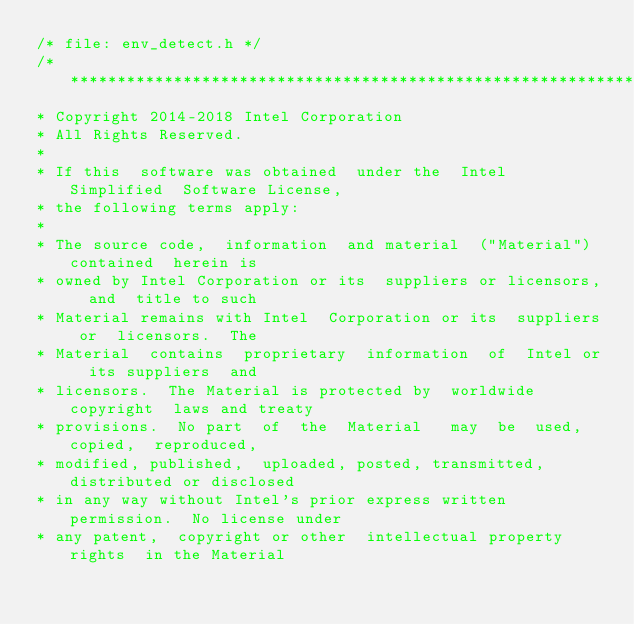<code> <loc_0><loc_0><loc_500><loc_500><_C_>/* file: env_detect.h */
/*******************************************************************************
* Copyright 2014-2018 Intel Corporation
* All Rights Reserved.
*
* If this  software was obtained  under the  Intel Simplified  Software License,
* the following terms apply:
*
* The source code,  information  and material  ("Material") contained  herein is
* owned by Intel Corporation or its  suppliers or licensors,  and  title to such
* Material remains with Intel  Corporation or its  suppliers or  licensors.  The
* Material  contains  proprietary  information  of  Intel or  its suppliers  and
* licensors.  The Material is protected by  worldwide copyright  laws and treaty
* provisions.  No part  of  the  Material   may  be  used,  copied,  reproduced,
* modified, published,  uploaded, posted, transmitted,  distributed or disclosed
* in any way without Intel's prior express written permission.  No license under
* any patent,  copyright or other  intellectual property rights  in the Material</code> 